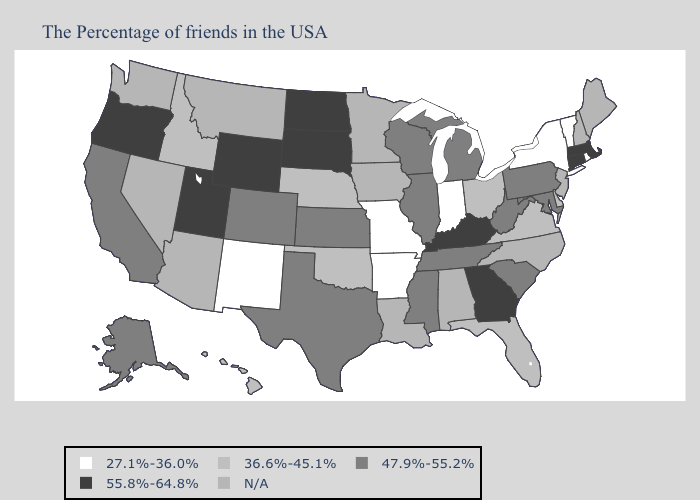What is the value of Alaska?
Answer briefly. 47.9%-55.2%. Name the states that have a value in the range 47.9%-55.2%?
Short answer required. Maryland, Pennsylvania, South Carolina, West Virginia, Michigan, Tennessee, Wisconsin, Illinois, Mississippi, Kansas, Texas, Colorado, California, Alaska. Does Idaho have the lowest value in the USA?
Concise answer only. No. Among the states that border Oregon , does California have the highest value?
Keep it brief. Yes. What is the highest value in the USA?
Write a very short answer. 55.8%-64.8%. Name the states that have a value in the range 27.1%-36.0%?
Keep it brief. Rhode Island, Vermont, New York, Indiana, Missouri, Arkansas, New Mexico. Name the states that have a value in the range 27.1%-36.0%?
Write a very short answer. Rhode Island, Vermont, New York, Indiana, Missouri, Arkansas, New Mexico. Which states have the lowest value in the Northeast?
Give a very brief answer. Rhode Island, Vermont, New York. Among the states that border New York , does Massachusetts have the lowest value?
Concise answer only. No. What is the value of Connecticut?
Concise answer only. 55.8%-64.8%. Which states have the lowest value in the USA?
Quick response, please. Rhode Island, Vermont, New York, Indiana, Missouri, Arkansas, New Mexico. Name the states that have a value in the range 55.8%-64.8%?
Answer briefly. Massachusetts, Connecticut, Georgia, Kentucky, South Dakota, North Dakota, Wyoming, Utah, Oregon. What is the lowest value in states that border New Jersey?
Answer briefly. 27.1%-36.0%. Among the states that border North Dakota , which have the lowest value?
Quick response, please. South Dakota. 